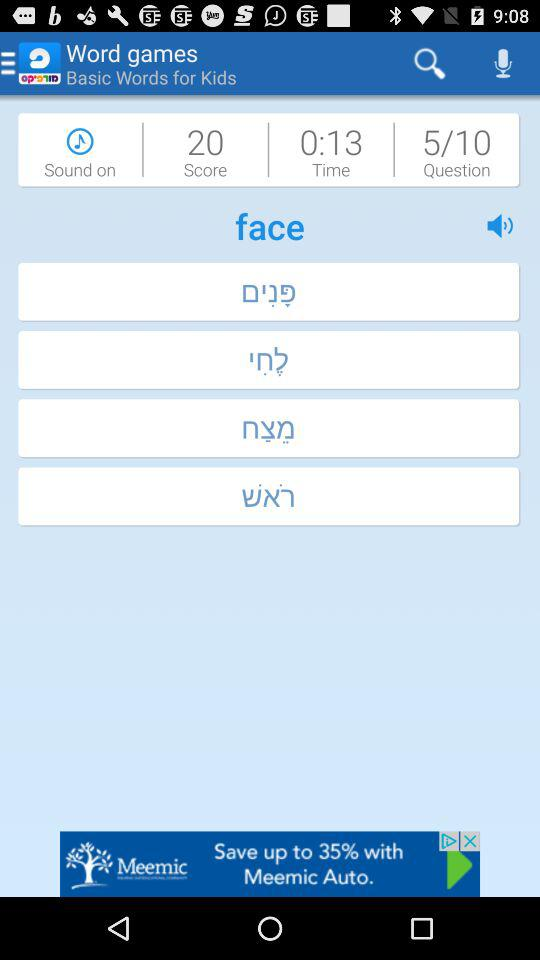How much time is left to answer? The time left to answer is 13 seconds. 